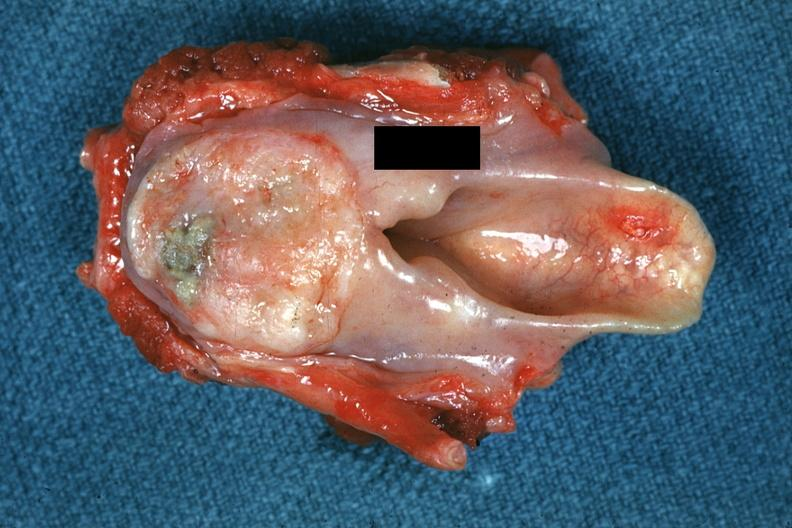s the superior vena cava present?
Answer the question using a single word or phrase. No 